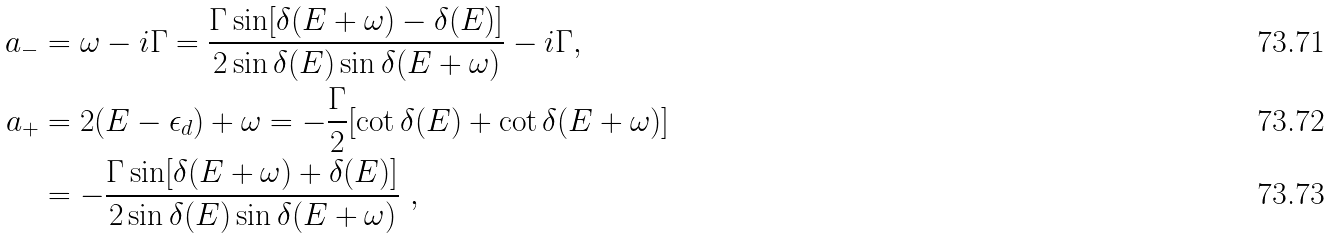<formula> <loc_0><loc_0><loc_500><loc_500>a _ { - } & = \omega - i \Gamma = \frac { \Gamma \sin [ \delta ( E + \omega ) - \delta ( E ) ] } { 2 \sin \delta ( E ) \sin \delta ( E + \omega ) } - i \Gamma , \\ a _ { + } & = 2 ( E - \epsilon _ { d } ) + \omega = - \frac { \Gamma } { 2 } [ \cot \delta ( E ) + \cot \delta ( E + \omega ) ] \\ & = - \frac { \Gamma \sin [ \delta ( E + \omega ) + \delta ( E ) ] } { 2 \sin \delta ( E ) \sin \delta ( E + \omega ) } \ ,</formula> 